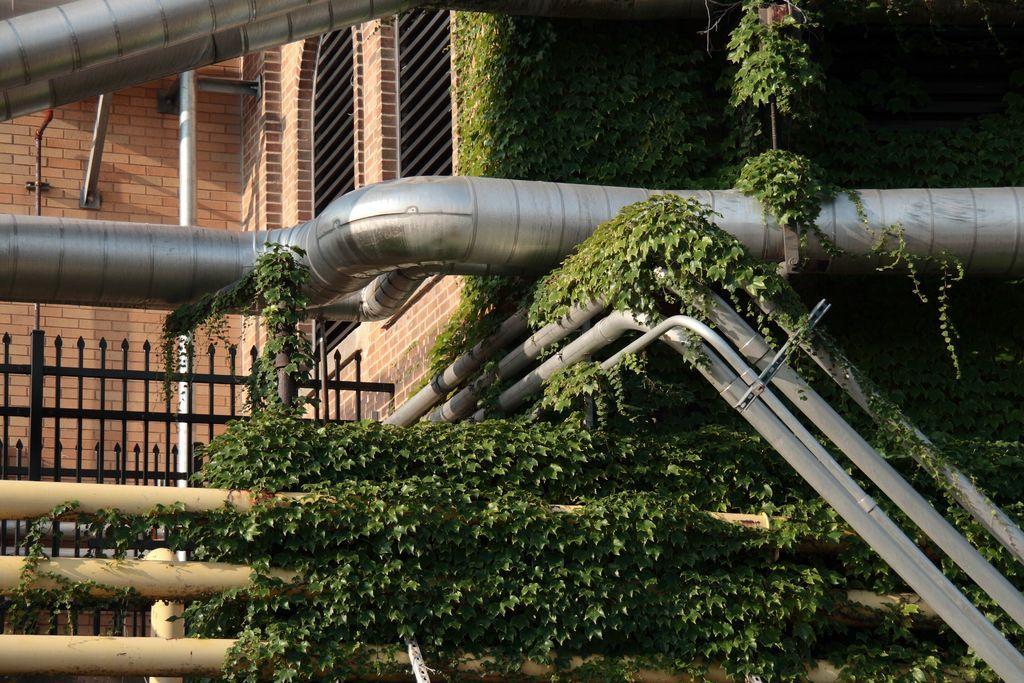In one or two sentences, can you explain what this image depicts? In this image we can see metal rods, creepers. In the background of the image there is fencing, wall and window. 